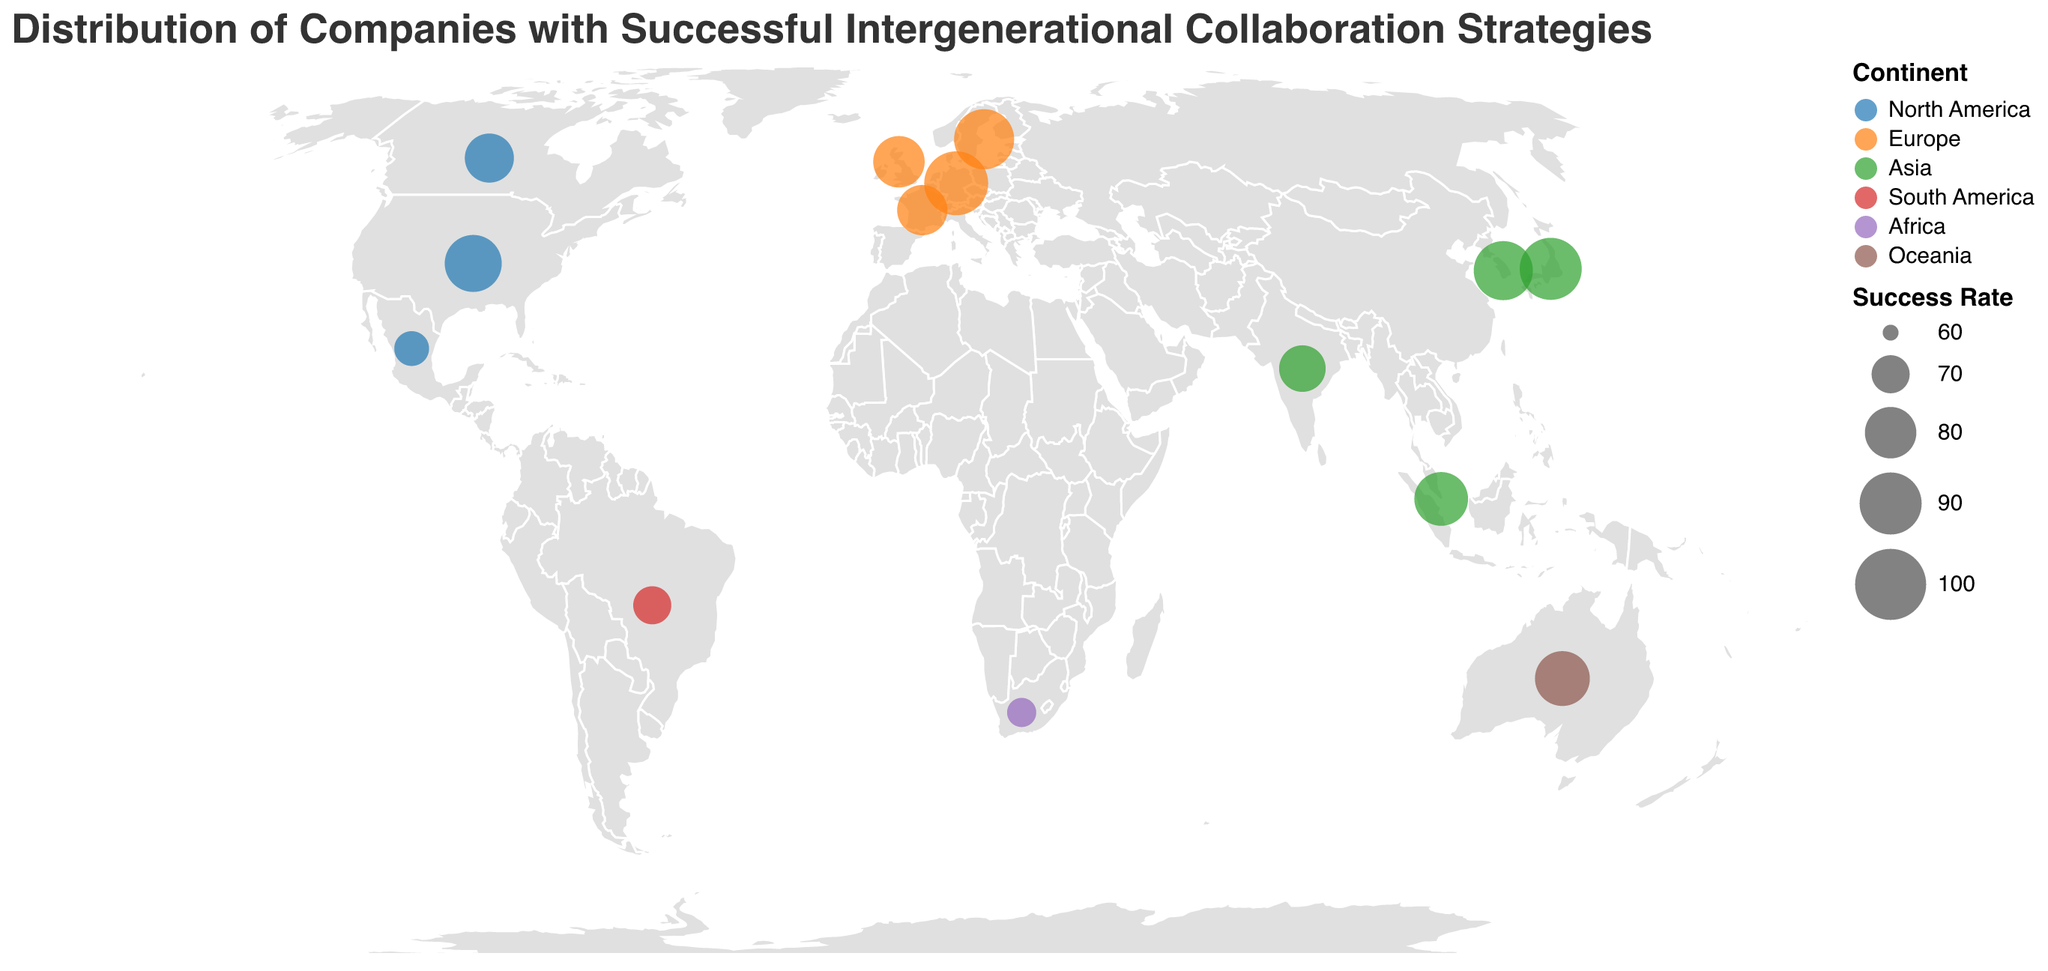Which continent has the most companies represented on the plot? By counting the number of data points (circles) for each continent, Europe is represented by 4 companies (Siemens, Unilever, IKEA, L'Oréal), which is the highest.
Answer: Europe Which country in Asia has the highest success rate? By looking at the data points and success rates for Asian countries, Japan (Toyota) has the highest success rate at 90.
Answer: Japan What is the success rate of the company in Australia? Locate the circle in Oceania (Australia) and check the success rate. Atlassian has a success rate of 83.
Answer: 83 Compare the success rates of companies in the United States and Canada. Which is higher? Look at the success rates for IBM (United States) and Shopify (Canada). IBM has 85 and Shopify has 78. Therefore, the United States has a higher success rate.
Answer: United States How many companies have a success rate above 80? Identify and count the data points with success rates above 80: IBM (85), Siemens (92), IKEA (88), Toyota (90), Samsung (87), DBS Bank (82), Atlassian (83). There are 7 companies in total.
Answer: 7 What is the average success rate of companies in Europe? Calculate the sum of success rates for European companies (Siemens 92, Unilever 80, IKEA 88, L'Oréal 79) and divide by the number of companies (4). The sum is 339, and the average is 339/4 = 84.75.
Answer: 84.75 Which continent has the lowest average success rate? Calculate the average success rate for each continent and compare:
- North America: (85 + 78 + 68) / 3 = 77
- Europe: (92 + 80 + 88 + 79) / 4 = 84.75
- Asia: (90 + 82 + 76 + 87) / 4 = 83.75
- South America: 70 / 1 = 70
- Africa: 65 / 1 = 65
- Oceania: 83 / 1 = 83.
Africa has the lowest average success rate of 65.
Answer: Africa Which continent hosts the company with the highest success rate? Identify the company with the highest success rate (Siemens) at 92, which is in Europe.
Answer: Europe What is the success rate difference between the companies in Mexico and Brazil? Subtract the success rate of Cemex in Mexico (68) from the success rate of Natura in Brazil (70). The difference is 70 - 68 = 2.
Answer: 2 How does the success rate of Tata Consultancy Services in India compare to that of Discovery Limited in South Africa? Compare the success rates: Tata Consultancy Services (76) and Discovery Limited (65). India has a higher success rate.
Answer: India 